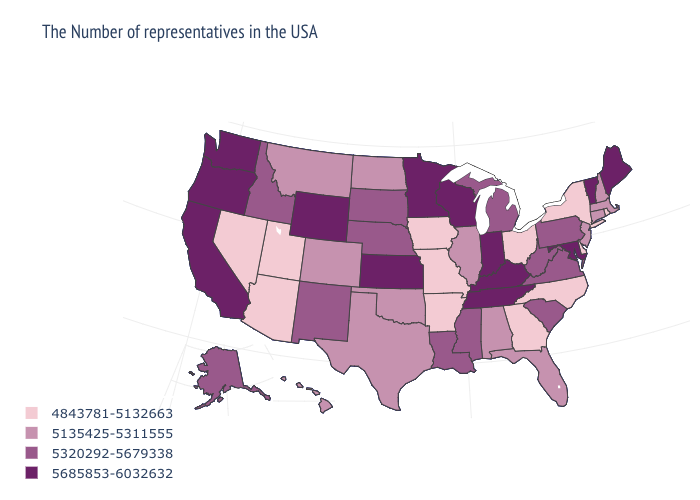Does New Mexico have a lower value than Texas?
Concise answer only. No. What is the value of North Dakota?
Keep it brief. 5135425-5311555. Name the states that have a value in the range 5320292-5679338?
Give a very brief answer. Pennsylvania, Virginia, South Carolina, West Virginia, Michigan, Mississippi, Louisiana, Nebraska, South Dakota, New Mexico, Idaho, Alaska. Which states have the lowest value in the USA?
Keep it brief. Rhode Island, New York, Delaware, North Carolina, Ohio, Georgia, Missouri, Arkansas, Iowa, Utah, Arizona, Nevada. What is the value of Maryland?
Be succinct. 5685853-6032632. Does Delaware have the lowest value in the USA?
Short answer required. Yes. Does Georgia have the lowest value in the USA?
Short answer required. Yes. Among the states that border Oregon , which have the highest value?
Quick response, please. California, Washington. Among the states that border Nevada , does Idaho have the highest value?
Write a very short answer. No. What is the value of Pennsylvania?
Answer briefly. 5320292-5679338. What is the value of Iowa?
Write a very short answer. 4843781-5132663. How many symbols are there in the legend?
Answer briefly. 4. Which states have the lowest value in the USA?
Answer briefly. Rhode Island, New York, Delaware, North Carolina, Ohio, Georgia, Missouri, Arkansas, Iowa, Utah, Arizona, Nevada. What is the value of Louisiana?
Answer briefly. 5320292-5679338. What is the value of Texas?
Give a very brief answer. 5135425-5311555. 